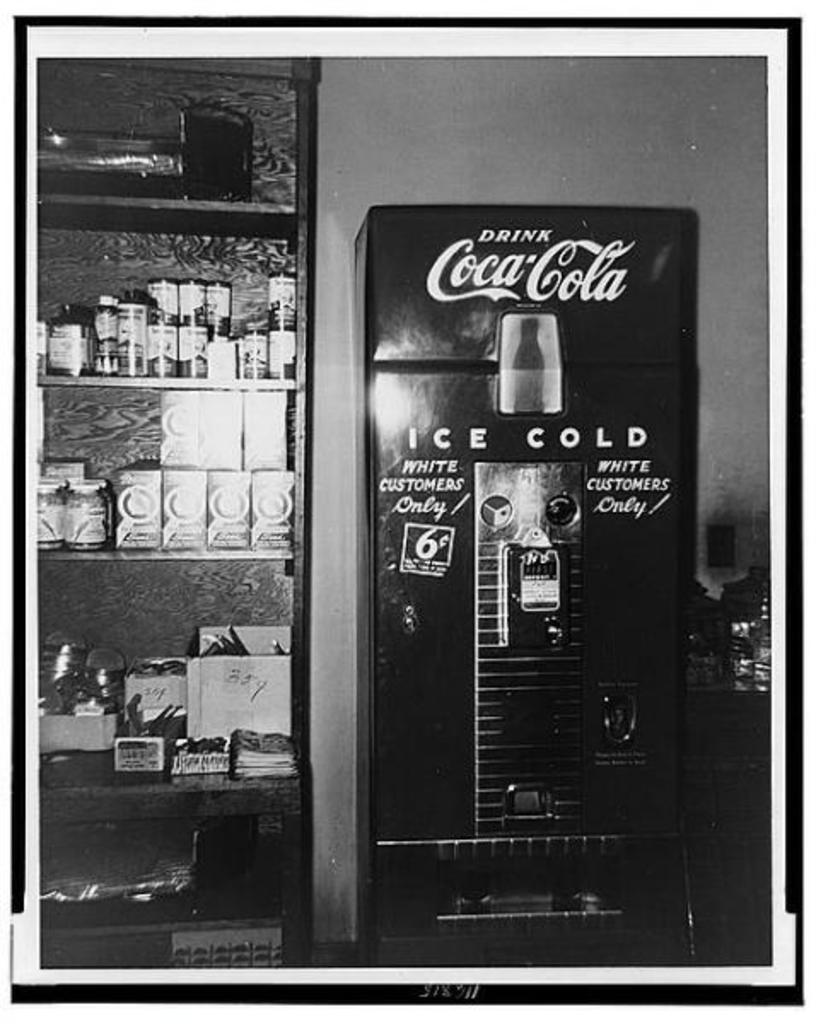<image>
Render a clear and concise summary of the photo. a machine that sells coca cola out of it 